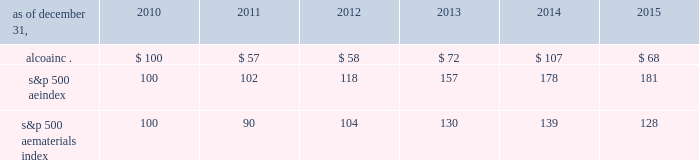Stock performance graph the following graph compares the most recent five-year performance of alcoa 2019s common stock with ( 1 ) the standard & poor 2019s 500 ae index and ( 2 ) the standard & poor 2019s 500 ae materials index , a group of 27 companies categorized by standard & poor 2019s as active in the 201cmaterials 201d market sector .
Such information shall not be deemed to be 201cfiled . 201d five-year cumulative total return based upon an initial investment of $ 100 on december 31 , 2010 with dividends reinvested alcoa inc .
S&p 500 ae index s&p 500 ae materials index dec-'10 dec-'11 dec-'12 dec-'14 dec-'15dec-'13 .
S&p 500 ae index 100 102 118 157 178 181 s&p 500 ae materials index 100 90 104 130 139 128 copyright a9 2016 standard & poor 2019s , a division of the mcgraw-hill companies inc .
All rights reserved .
Source : research data group , inc .
( www.researchdatagroup.com/s&p.htm ) .
What was the percentual increase observed in the alcoainc . investment during 2013 and 2014? 
Rationale: it is the price in 2014 ( $ 107 ) divided by the price in 2013 ( $ 72 ) then subtracted 1 and turned into a percentage .
Computations: ((107 / 72) - 1)
Answer: 0.48611. 